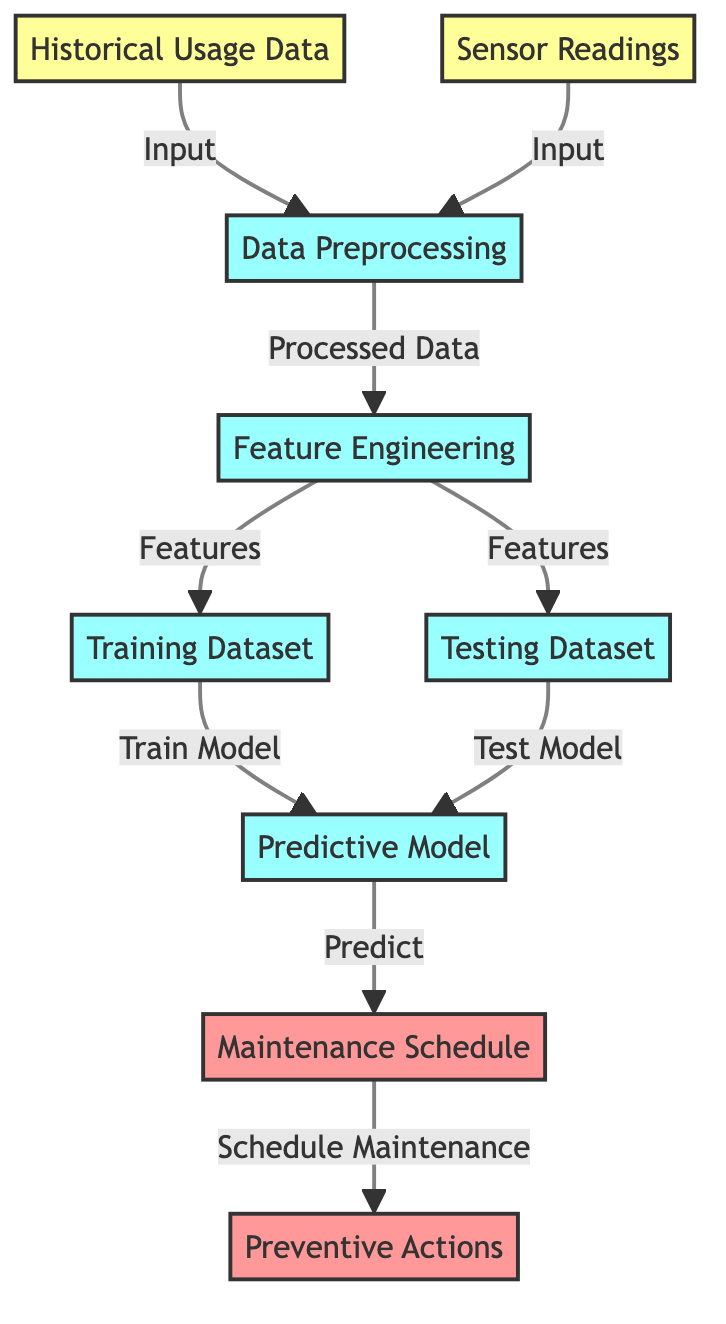What are the inputs to the data preprocessing node? The inputs to the data preprocessing node are "Historical Usage Data" and "Sensor Readings," as indicated by the arrows leading into the data preprocessing node.
Answer: Historical Usage Data, Sensor Readings How many nodes are present in the diagram? The diagram presents a total of 9 nodes, which include input, process, and output nodes. This count is achieved by visually scanning for the labeled squares and ovals in the diagram.
Answer: 9 Which node outputs the maintenance schedule? The node that outputs the maintenance schedule is "Predictive Model," which points to the node labeled "Maintenance Schedule." This can be confirmed by following the directional arrow from the predictive model to the maintenance schedule.
Answer: Maintenance Schedule What type of model is being trained in the diagram? The model being trained is a "Predictive Model," as explicitly named in the appropriate node in the diagram. This information is directly derived from the labeling of the node.
Answer: Predictive Model How does the feature engineering node connect in the process? The feature engineering node connects to two nodes: "Training Dataset" and "Testing Dataset," suggesting that it provides features necessary for both datasets, which is indicated by arrows leading from feature engineering to these two nodes.
Answer: Training Dataset, Testing Dataset What is the final output suggested for the predictive model? The final output suggested for the predictive model is "Preventive Actions," as indicated by the arrow leading from the "Maintenance Schedule" node to the "Preventive Actions" node.
Answer: Preventive Actions What is the purpose of the data preprocessing node? The purpose of the data preprocessing node is to take input data (historical usage data and sensor readings) and convert it into "Processed Data." This can be determined by the directed flow from the input nodes to the preprocessing node and its label.
Answer: Processed Data What is the flow direction from the training dataset to the predictive model? The flow direction is from the "Training Dataset" to the "Predictive Model," identified by the arrow pointing from the training dataset node to the predictive model node, signifying the training process.
Answer: Train Model Which type of actions are recommended based on the maintenance schedule? The recommended actions according to the maintenance schedule are "Preventive Actions," as illustrated in the output node directly following the maintenance schedule node in the diagram.
Answer: Preventive Actions 